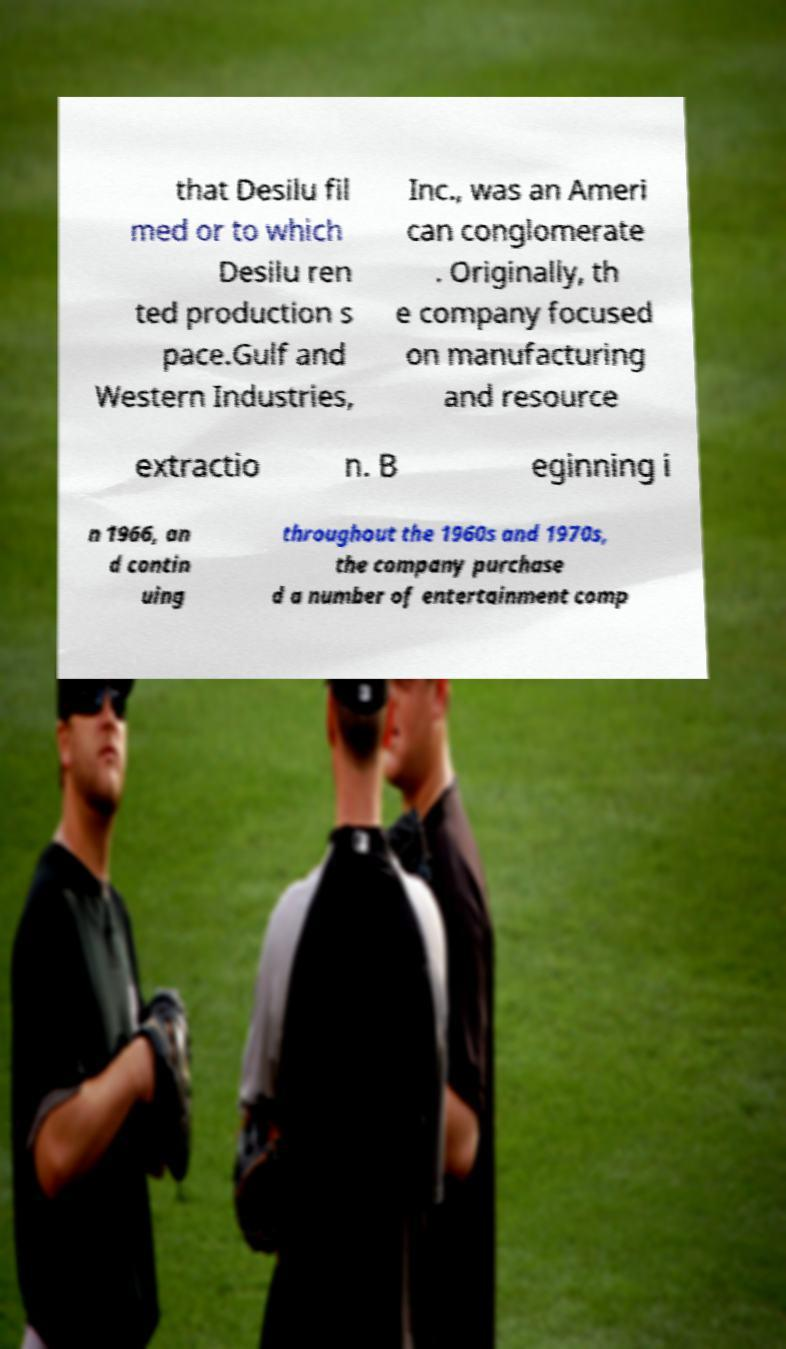I need the written content from this picture converted into text. Can you do that? that Desilu fil med or to which Desilu ren ted production s pace.Gulf and Western Industries, Inc., was an Ameri can conglomerate . Originally, th e company focused on manufacturing and resource extractio n. B eginning i n 1966, an d contin uing throughout the 1960s and 1970s, the company purchase d a number of entertainment comp 